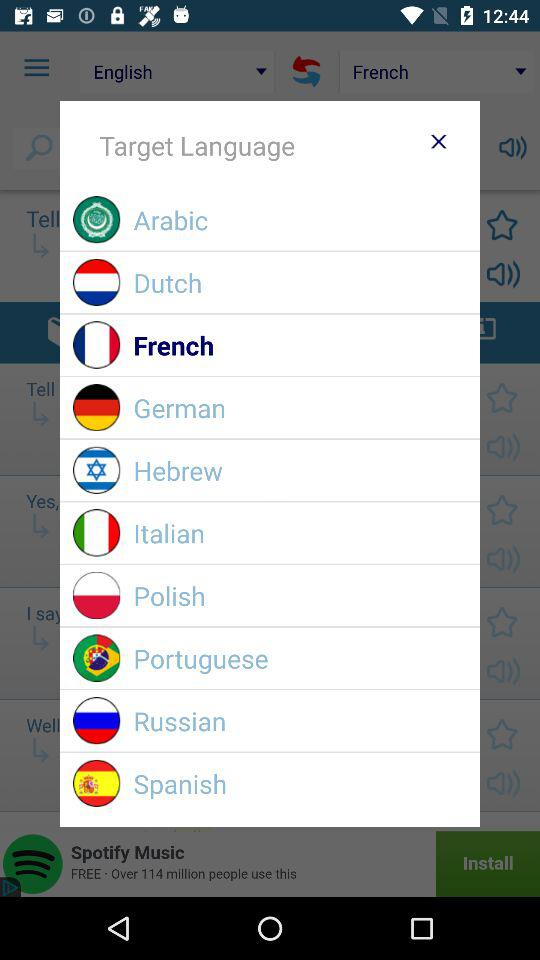Which word is chosen for translation?
When the provided information is insufficient, respond with <no answer>. <no answer> 